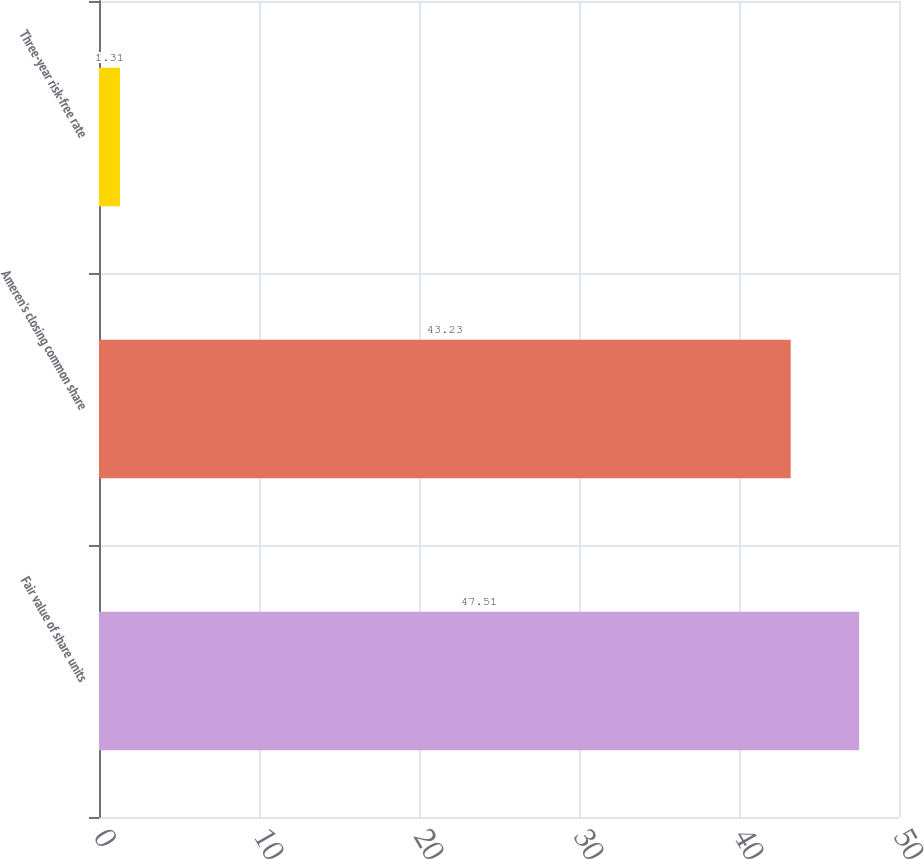<chart> <loc_0><loc_0><loc_500><loc_500><bar_chart><fcel>Fair value of share units<fcel>Ameren's closing common share<fcel>Three-year risk-free rate<nl><fcel>47.51<fcel>43.23<fcel>1.31<nl></chart> 